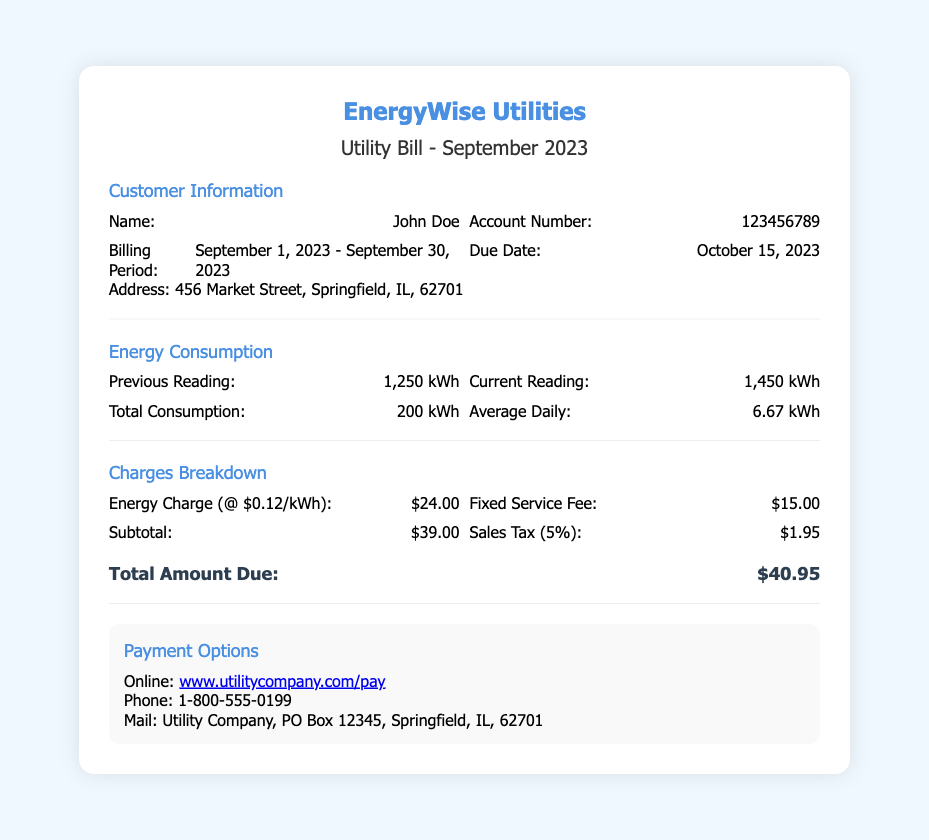What is the name of the customer? The customer's name is presented at the top of the document under Customer Information.
Answer: John Doe What is the account number? The account number is provided next to the customer's name in the Customer Information section.
Answer: 123456789 What is the billing period? The billing period is indicated in the Customer Information section.
Answer: September 1, 2023 - September 30, 2023 What is the current reading of the meter? The current reading is listed in the Energy Consumption section.
Answer: 1,450 kWh What is the total consumption of energy? Total consumption is calculated from the previous and current reading in the Energy Consumption section.
Answer: 200 kWh What is the sales tax amount? The sales tax is provided in the Charges Breakdown section.
Answer: $1.95 What is the total amount due? The total amount due is calculated in the Charges Breakdown section.
Answer: $40.95 What is the energy charge rate? The energy charge rate is mentioned next to the energy charge in the Charges Breakdown section.
Answer: $0.12/kWh When is the due date for payment? The due date is specified in the Customer Information section.
Answer: October 15, 2023 